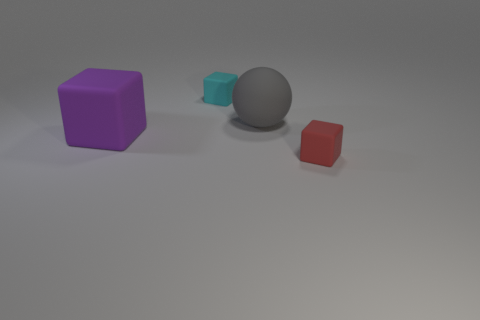What number of things are either tiny rubber cubes behind the large purple matte thing or matte objects in front of the large gray rubber sphere?
Your response must be concise. 3. What number of cyan rubber cubes are in front of the tiny block that is on the left side of the tiny matte thing that is in front of the small cyan thing?
Your answer should be very brief. 0. How big is the rubber cube in front of the purple cube?
Offer a very short reply. Small. What number of spheres are the same size as the purple block?
Offer a very short reply. 1. Do the gray rubber object and the matte cube to the right of the cyan matte block have the same size?
Ensure brevity in your answer.  No. What number of objects are tiny gray spheres or gray rubber balls?
Provide a short and direct response. 1. What number of matte cubes are the same color as the big matte ball?
Make the answer very short. 0. There is a cyan matte object that is the same size as the red block; what shape is it?
Give a very brief answer. Cube. Is there a gray thing that has the same shape as the red thing?
Give a very brief answer. No. How many large gray things are made of the same material as the gray sphere?
Your answer should be very brief. 0. 